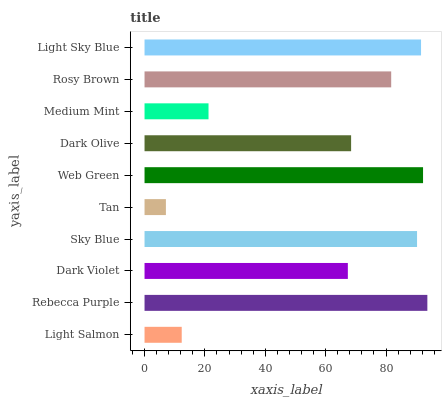Is Tan the minimum?
Answer yes or no. Yes. Is Rebecca Purple the maximum?
Answer yes or no. Yes. Is Dark Violet the minimum?
Answer yes or no. No. Is Dark Violet the maximum?
Answer yes or no. No. Is Rebecca Purple greater than Dark Violet?
Answer yes or no. Yes. Is Dark Violet less than Rebecca Purple?
Answer yes or no. Yes. Is Dark Violet greater than Rebecca Purple?
Answer yes or no. No. Is Rebecca Purple less than Dark Violet?
Answer yes or no. No. Is Rosy Brown the high median?
Answer yes or no. Yes. Is Dark Olive the low median?
Answer yes or no. Yes. Is Dark Violet the high median?
Answer yes or no. No. Is Rosy Brown the low median?
Answer yes or no. No. 